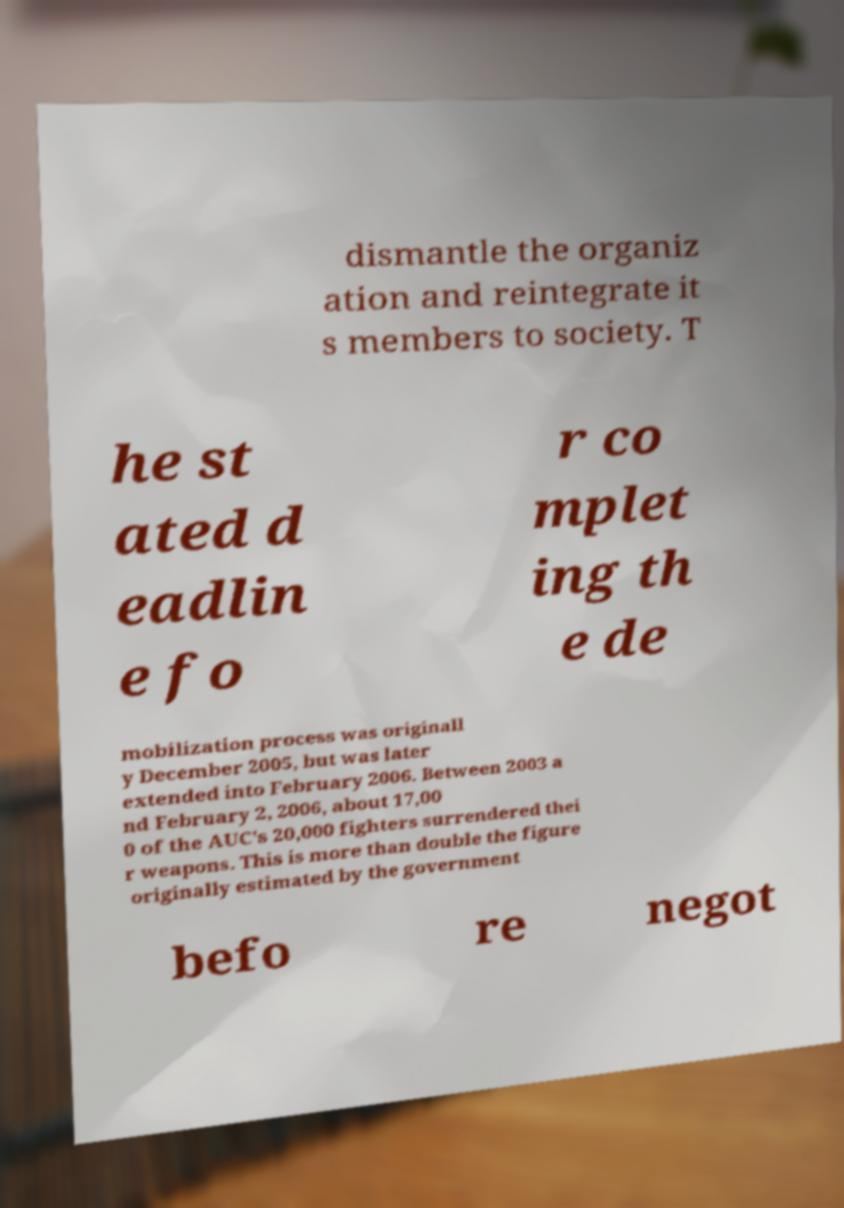I need the written content from this picture converted into text. Can you do that? dismantle the organiz ation and reintegrate it s members to society. T he st ated d eadlin e fo r co mplet ing th e de mobilization process was originall y December 2005, but was later extended into February 2006. Between 2003 a nd February 2, 2006, about 17,00 0 of the AUC's 20,000 fighters surrendered thei r weapons. This is more than double the figure originally estimated by the government befo re negot 